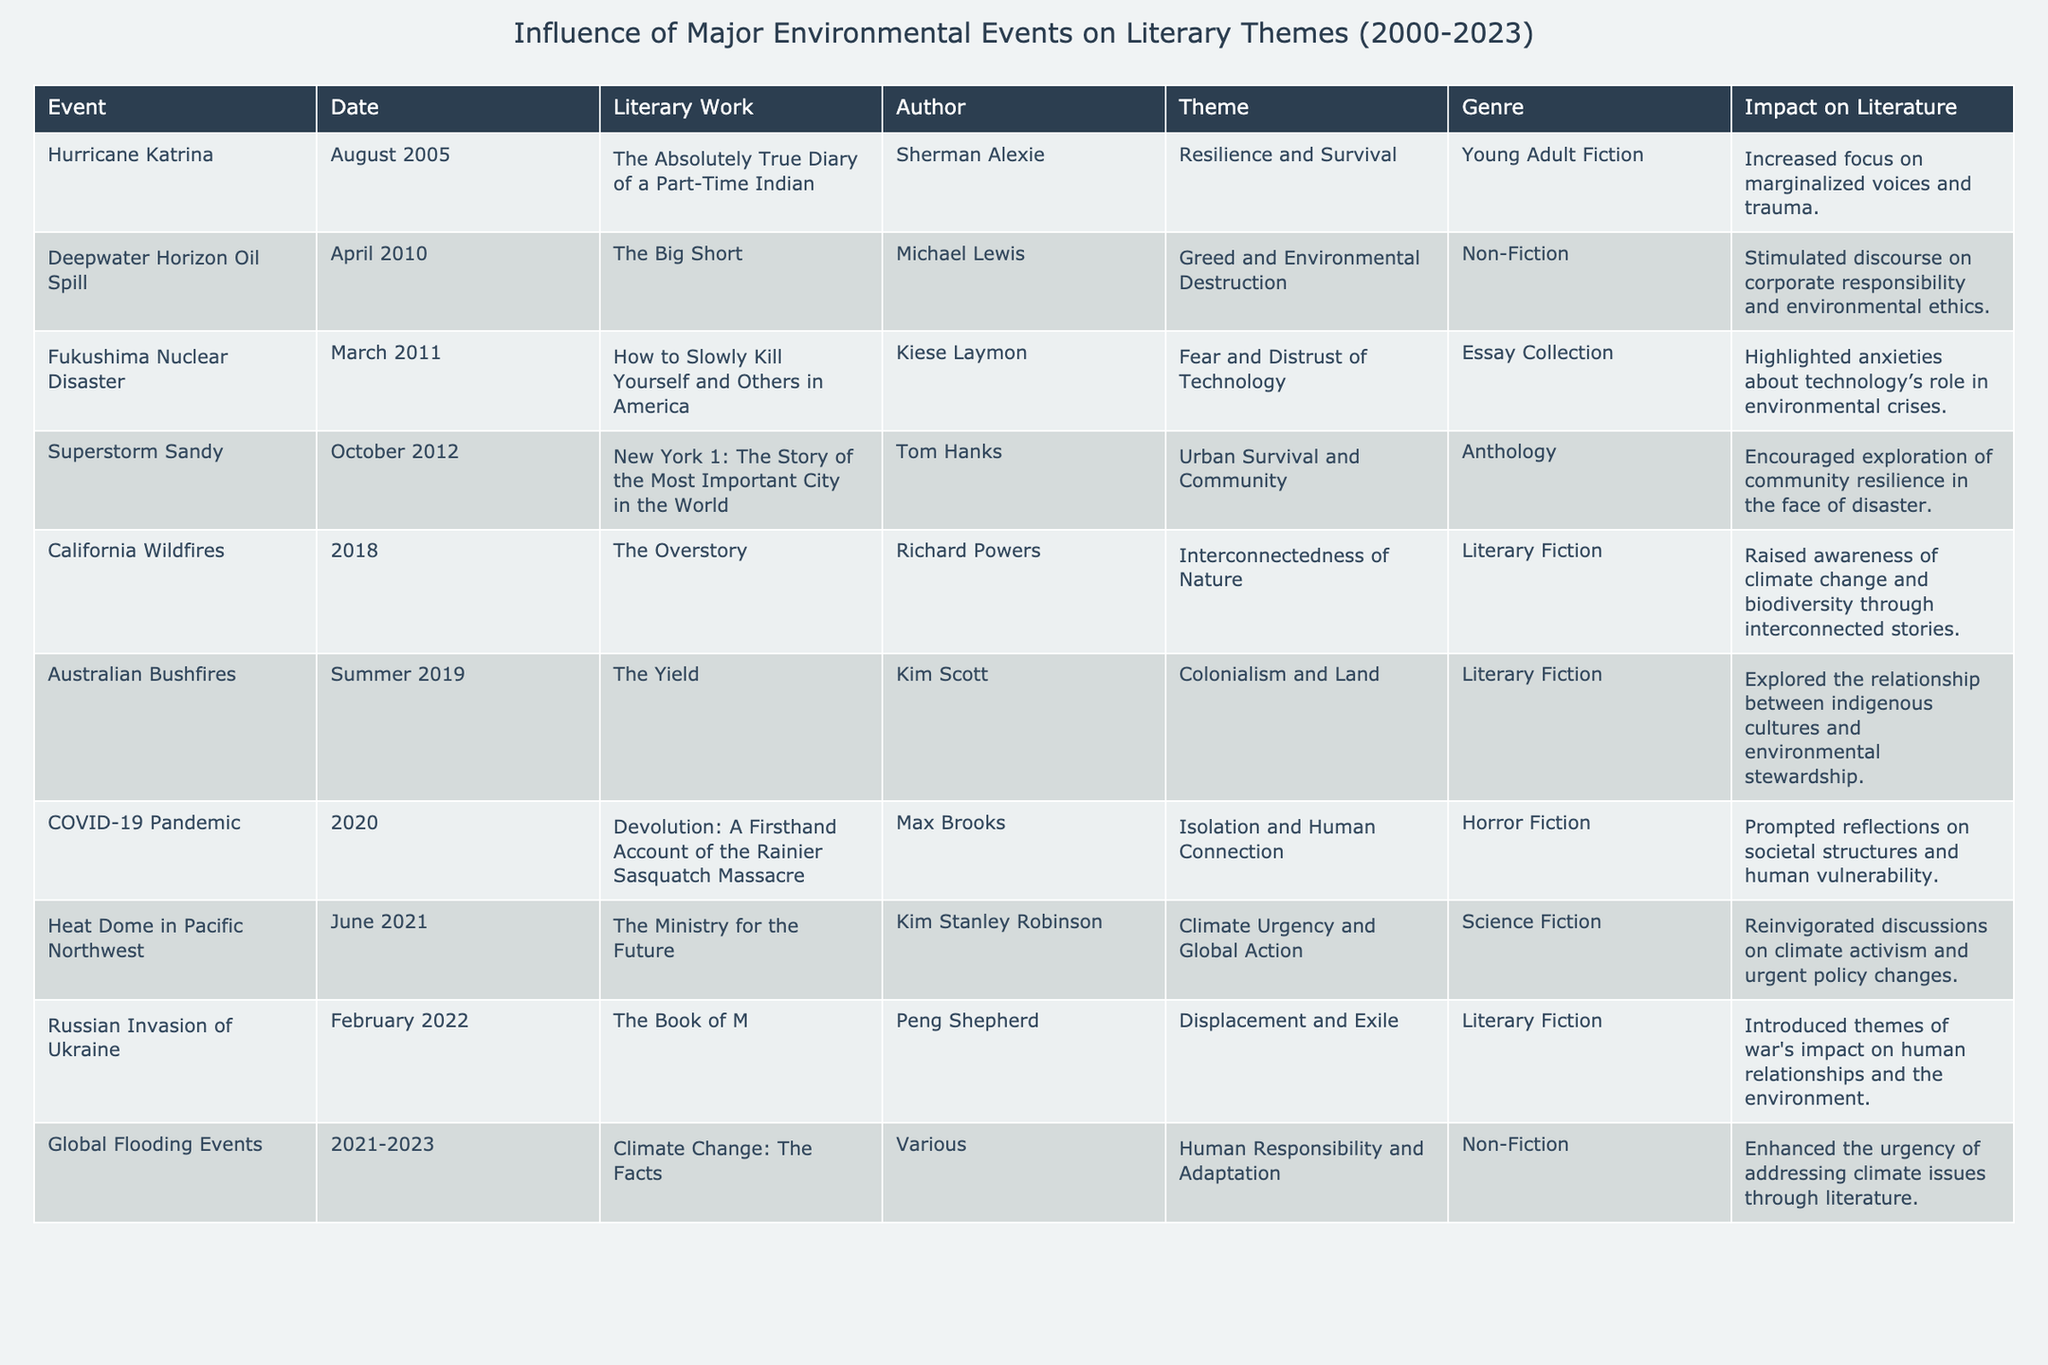What event is associated with the theme of "Isolation and Human Connection"? The table indicates that the COVID-19 Pandemic is linked with the theme of "Isolation and Human Connection," as stated in the corresponding row.
Answer: COVID-19 Pandemic Which author's work discusses "Urban Survival and Community"? According to the table, Tom Hanks is the author associated with the work "New York 1: The Story of the Most Important City in the World," which focuses on the theme of "Urban Survival and Community."
Answer: Tom Hanks How many events listed correspond to the genre of Literary Fiction? By examining the table, we find that there are three works categorized under Literary Fiction: "The Overstory," "The Yield," and "The Book of M." Counting these gives us a total of three events.
Answer: 3 Did Hurricane Katrina influence themes related to environmental ethics? The table shows that Hurricane Katrina is linked to the theme of "Resilience and Survival" and does not mention environmental ethics. Therefore, the answer is no.
Answer: No What theme is common between the California Wildfires and the Australian Bushfires? Both events focus on themes related to the environment; the California Wildfires discuss "Interconnectedness of Nature," while the Australian Bushfires explore "Colonialism and Land." However, they do not share a common theme but both highlight environmental issues.
Answer: No common theme Which literary work addresses the impact of war on human relationships and the environment? The table specifies that "The Book of M" by Peng Shepherd addresses the theme of "Displacement and Exile," which links the impact of war on human relationships and the environment.
Answer: The Book of M What genre is most represented in the major environmental events listed in the table? Upon reviewing the table, the genres of the works vary; however, literary fiction appears multiple times for different events, suggesting it is the most represented genre overall.
Answer: Literary Fiction What was the impact of Superstorm Sandy on literature? The table notes that the impact of Superstorm Sandy on literature encouraged exploration of community resilience in the face of disaster. This indicates it prompted significant literary discussions.
Answer: Exploration of community resilience How does the theme "Fear and Distrust of Technology" relate to the Fukushima Nuclear Disaster? The table states that Kiese Laymon's work, "How to Slowly Kill Yourself and Others in America," discusses "Fear and Distrust of Technology," directly linking it to the Fukushima Nuclear Disaster event.
Answer: Directly related What is the significance of the term "interconnectedness" as used in "The Overstory"? In the context of "The Overstory," the term "interconnectedness" relates to the impact of California Wildfires on themes of climate change and biodiversity, emphasizing the profound connections within nature and human experiences.
Answer: Impact on climate change and biodiversity 